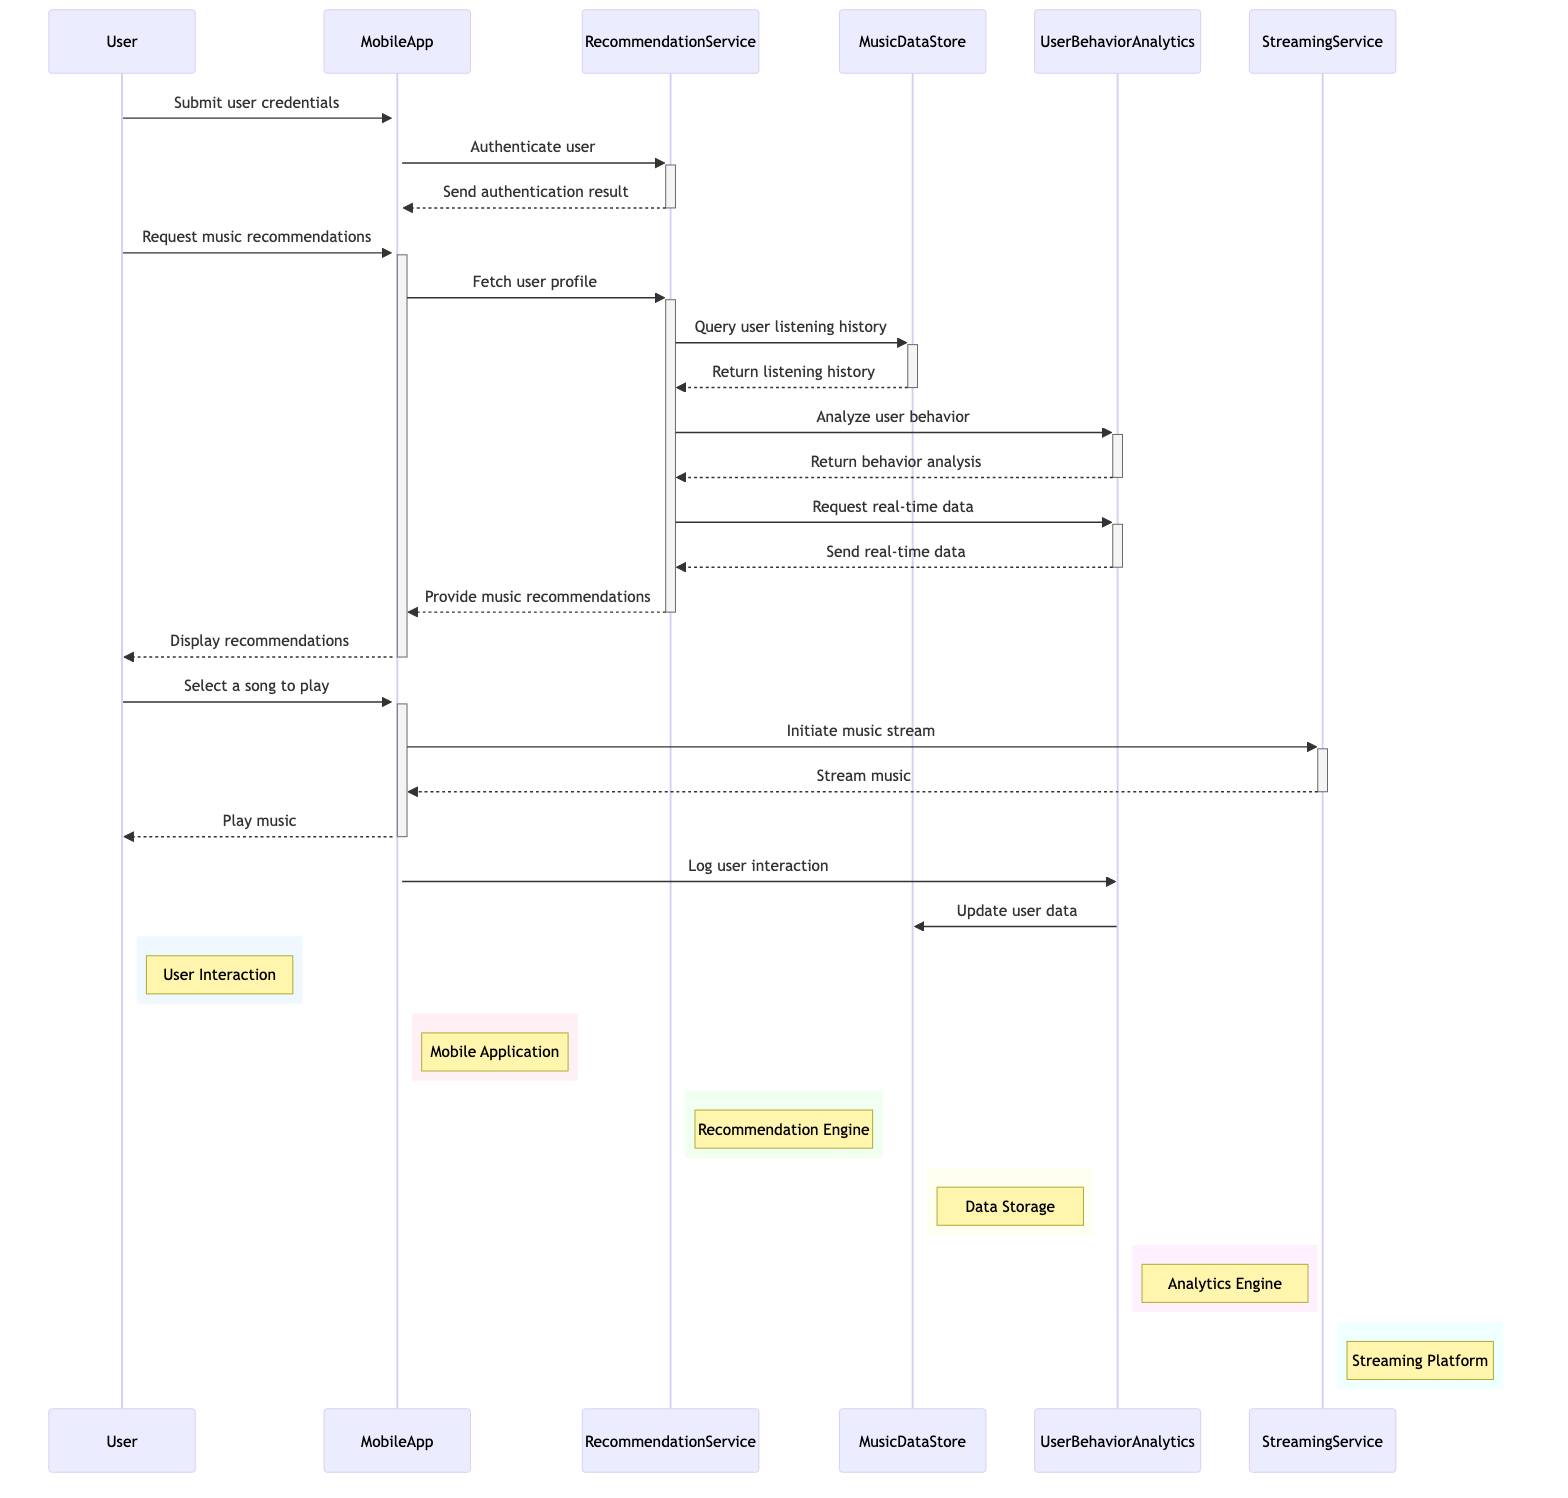what is the total number of participants in the diagram? The diagram lists six participants: User, MobileApp, RecommendationService, MusicDataStore, UserBehaviorAnalytics, and StreamingService. Therefore, the total count is six.
Answer: six which participant authenticates the user? The MobileApp sends a request to the RecommendationService to authenticate the user, making the RecommendationService responsible for the authentication process.
Answer: RecommendationService what does the MobileApp display to the User? After receiving recommendations from the RecommendationService, the MobileApp presents these recommendations to the User. Therefore, the content displayed is music recommendations.
Answer: music recommendations how many times does the RecommendationService analyze user behavior? The RecommendationService analyzes user behavior once by sending a request to the UserBehaviorAnalytics object, which processes and returns the behavior analysis. Hence, it is a single occurrence.
Answer: once which object is responsible for logging user interactions? The MobileApp is responsible for logging user interactions, as it sends a logging message to the UserBehaviorAnalytics after the User interacts with the application.
Answer: MobileApp what is the purpose of the request made by the RecommendationService to UserBehaviorAnalytics? The RecommendationService requests real-time data from the UserBehaviorAnalytics to enhance its recommendation process, ensuring dynamic and personalized music suggestions.
Answer: Request real-time data how does the User initiate the music streaming process? The User selects a song to play and sends this selection to the MobileApp, prompting it to initiate the music stream through the StreamingService. This connection illustrates the flow from user input to music access.
Answer: By selecting a song 